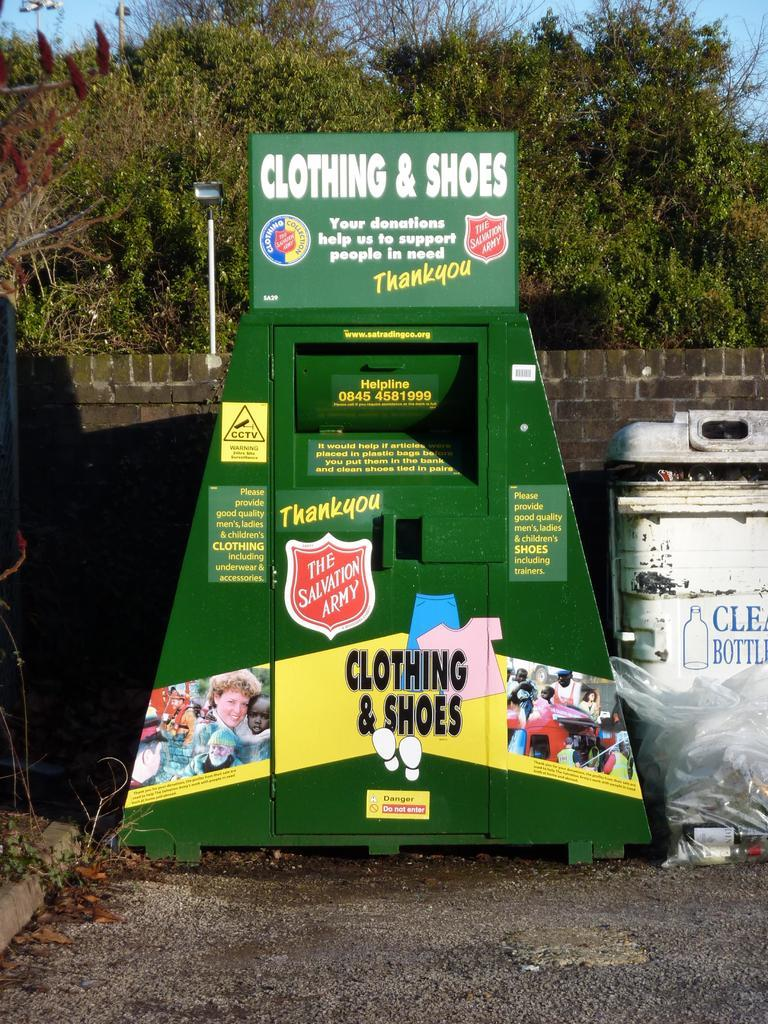<image>
Summarize the visual content of the image. Green donation bin which says "Clothing & Shoes" on the top. 